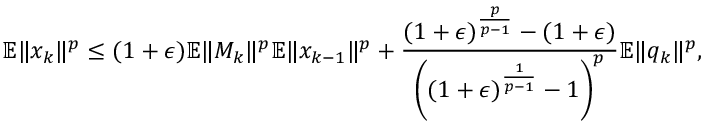Convert formula to latex. <formula><loc_0><loc_0><loc_500><loc_500>\mathbb { E } \| x _ { k } \| ^ { p } \leq ( 1 + \epsilon ) \mathbb { E } \| M _ { k } \| ^ { p } \mathbb { E } \| x _ { k - 1 } \| ^ { p } + \frac { ( 1 + \epsilon ) ^ { \frac { p } { p - 1 } } - ( 1 + \epsilon ) } { \left ( ( 1 + \epsilon ) ^ { \frac { 1 } { p - 1 } } - 1 \right ) ^ { p } } \mathbb { E } \| q _ { k } \| ^ { p } ,</formula> 